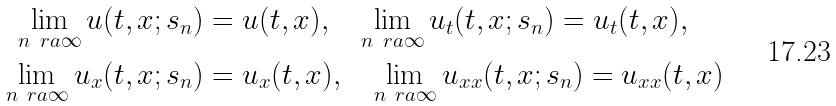Convert formula to latex. <formula><loc_0><loc_0><loc_500><loc_500>\lim _ { n \ r a \infty } u ( t , x ; s _ { n } ) & = u ( t , x ) , \quad \lim _ { n \ r a \infty } u _ { t } ( t , x ; s _ { n } ) = u _ { t } ( t , x ) , \\ \lim _ { n \ r a \infty } u _ { x } ( t , x ; s _ { n } ) & = u _ { x } ( t , x ) , \quad \lim _ { n \ r a \infty } u _ { x x } ( t , x ; s _ { n } ) = u _ { x x } ( t , x )</formula> 